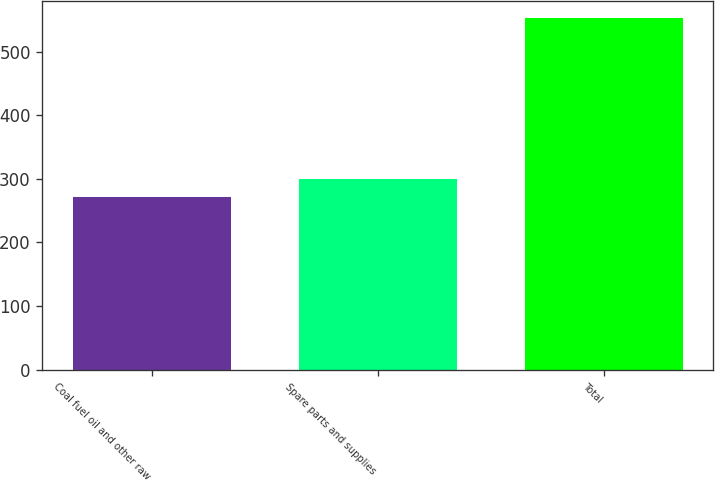Convert chart to OTSL. <chart><loc_0><loc_0><loc_500><loc_500><bar_chart><fcel>Coal fuel oil and other raw<fcel>Spare parts and supplies<fcel>Total<nl><fcel>272<fcel>300<fcel>552<nl></chart> 